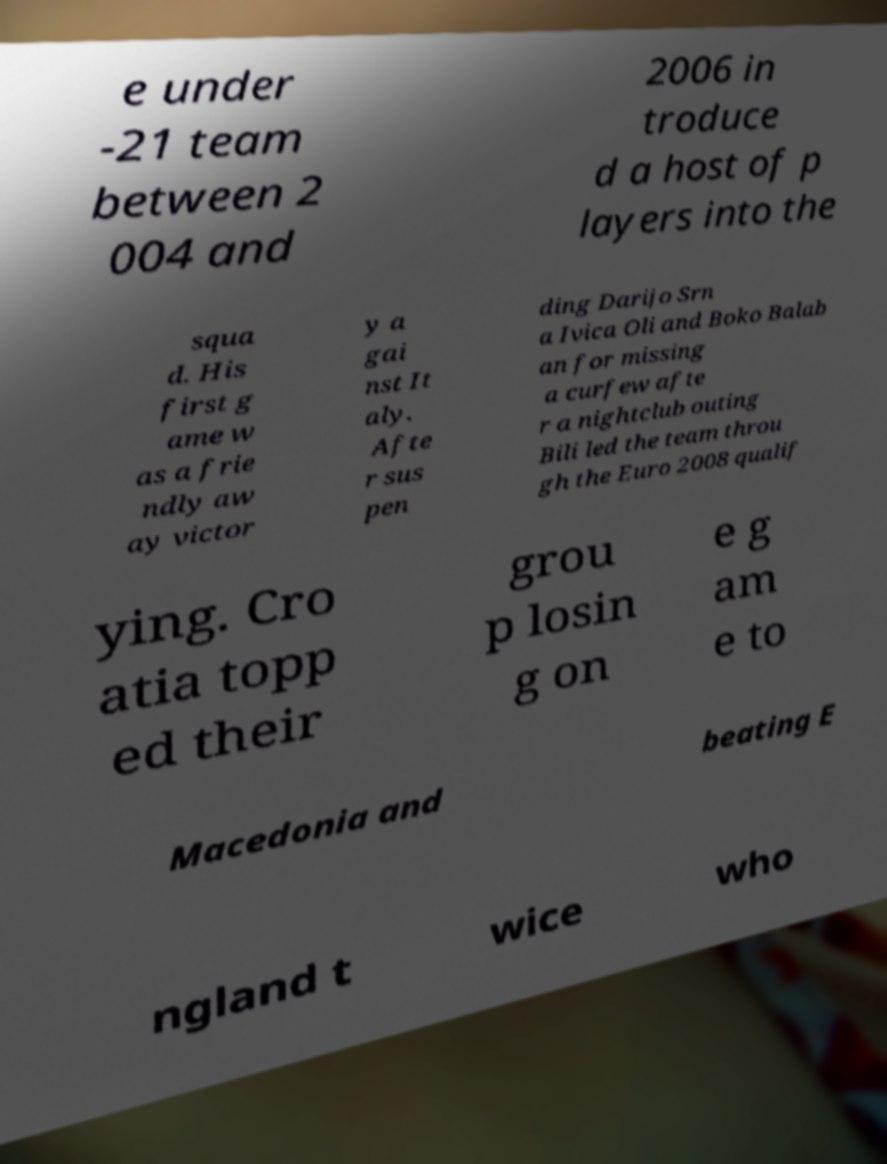Can you read and provide the text displayed in the image?This photo seems to have some interesting text. Can you extract and type it out for me? e under -21 team between 2 004 and 2006 in troduce d a host of p layers into the squa d. His first g ame w as a frie ndly aw ay victor y a gai nst It aly. Afte r sus pen ding Darijo Srn a Ivica Oli and Boko Balab an for missing a curfew afte r a nightclub outing Bili led the team throu gh the Euro 2008 qualif ying. Cro atia topp ed their grou p losin g on e g am e to Macedonia and beating E ngland t wice who 